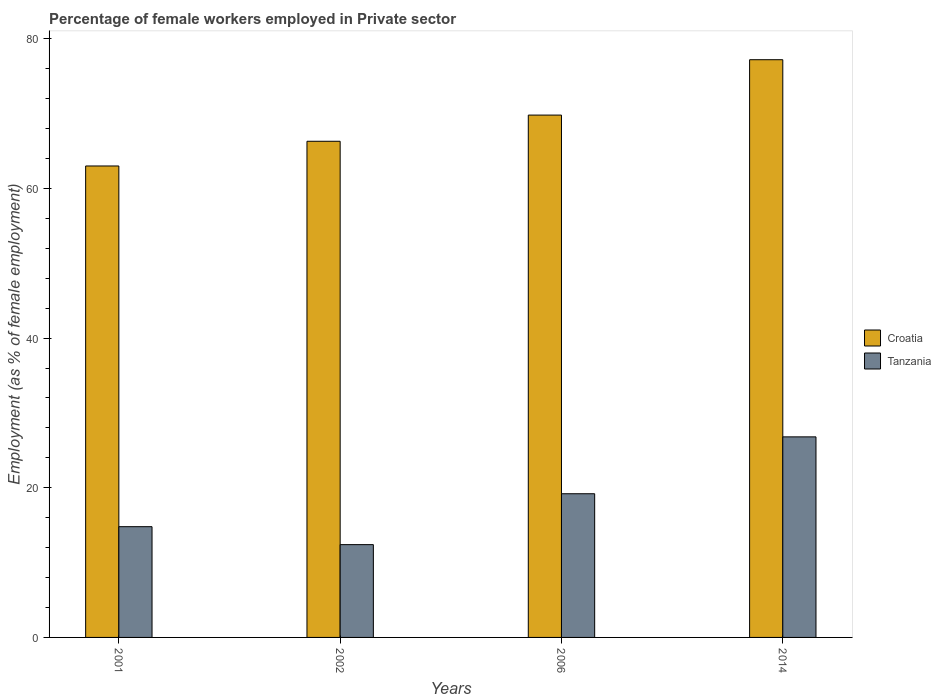How many groups of bars are there?
Your response must be concise. 4. Are the number of bars per tick equal to the number of legend labels?
Provide a succinct answer. Yes. How many bars are there on the 2nd tick from the right?
Provide a short and direct response. 2. What is the label of the 4th group of bars from the left?
Keep it short and to the point. 2014. What is the percentage of females employed in Private sector in Tanzania in 2014?
Your response must be concise. 26.8. Across all years, what is the maximum percentage of females employed in Private sector in Tanzania?
Make the answer very short. 26.8. Across all years, what is the minimum percentage of females employed in Private sector in Croatia?
Give a very brief answer. 63. In which year was the percentage of females employed in Private sector in Croatia maximum?
Ensure brevity in your answer.  2014. In which year was the percentage of females employed in Private sector in Croatia minimum?
Provide a succinct answer. 2001. What is the total percentage of females employed in Private sector in Tanzania in the graph?
Keep it short and to the point. 73.2. What is the difference between the percentage of females employed in Private sector in Tanzania in 2001 and that in 2006?
Provide a succinct answer. -4.4. What is the difference between the percentage of females employed in Private sector in Tanzania in 2001 and the percentage of females employed in Private sector in Croatia in 2006?
Provide a short and direct response. -55. What is the average percentage of females employed in Private sector in Tanzania per year?
Offer a very short reply. 18.3. In the year 2001, what is the difference between the percentage of females employed in Private sector in Croatia and percentage of females employed in Private sector in Tanzania?
Your response must be concise. 48.2. What is the ratio of the percentage of females employed in Private sector in Tanzania in 2002 to that in 2014?
Give a very brief answer. 0.46. Is the percentage of females employed in Private sector in Tanzania in 2001 less than that in 2002?
Keep it short and to the point. No. What is the difference between the highest and the second highest percentage of females employed in Private sector in Tanzania?
Provide a succinct answer. 7.6. What is the difference between the highest and the lowest percentage of females employed in Private sector in Tanzania?
Provide a short and direct response. 14.4. In how many years, is the percentage of females employed in Private sector in Tanzania greater than the average percentage of females employed in Private sector in Tanzania taken over all years?
Provide a short and direct response. 2. What does the 1st bar from the left in 2001 represents?
Give a very brief answer. Croatia. What does the 1st bar from the right in 2014 represents?
Offer a terse response. Tanzania. How many bars are there?
Keep it short and to the point. 8. How many years are there in the graph?
Keep it short and to the point. 4. Are the values on the major ticks of Y-axis written in scientific E-notation?
Provide a succinct answer. No. Does the graph contain any zero values?
Ensure brevity in your answer.  No. Does the graph contain grids?
Your response must be concise. No. Where does the legend appear in the graph?
Give a very brief answer. Center right. What is the title of the graph?
Provide a succinct answer. Percentage of female workers employed in Private sector. Does "Brunei Darussalam" appear as one of the legend labels in the graph?
Keep it short and to the point. No. What is the label or title of the X-axis?
Keep it short and to the point. Years. What is the label or title of the Y-axis?
Provide a short and direct response. Employment (as % of female employment). What is the Employment (as % of female employment) of Croatia in 2001?
Offer a terse response. 63. What is the Employment (as % of female employment) in Tanzania in 2001?
Make the answer very short. 14.8. What is the Employment (as % of female employment) in Croatia in 2002?
Provide a short and direct response. 66.3. What is the Employment (as % of female employment) in Tanzania in 2002?
Give a very brief answer. 12.4. What is the Employment (as % of female employment) in Croatia in 2006?
Keep it short and to the point. 69.8. What is the Employment (as % of female employment) of Tanzania in 2006?
Your response must be concise. 19.2. What is the Employment (as % of female employment) of Croatia in 2014?
Provide a short and direct response. 77.2. What is the Employment (as % of female employment) of Tanzania in 2014?
Ensure brevity in your answer.  26.8. Across all years, what is the maximum Employment (as % of female employment) in Croatia?
Make the answer very short. 77.2. Across all years, what is the maximum Employment (as % of female employment) in Tanzania?
Your answer should be very brief. 26.8. Across all years, what is the minimum Employment (as % of female employment) of Croatia?
Keep it short and to the point. 63. Across all years, what is the minimum Employment (as % of female employment) of Tanzania?
Your response must be concise. 12.4. What is the total Employment (as % of female employment) of Croatia in the graph?
Make the answer very short. 276.3. What is the total Employment (as % of female employment) in Tanzania in the graph?
Your answer should be compact. 73.2. What is the difference between the Employment (as % of female employment) of Croatia in 2001 and that in 2002?
Provide a short and direct response. -3.3. What is the difference between the Employment (as % of female employment) of Tanzania in 2001 and that in 2002?
Ensure brevity in your answer.  2.4. What is the difference between the Employment (as % of female employment) in Tanzania in 2001 and that in 2006?
Your answer should be very brief. -4.4. What is the difference between the Employment (as % of female employment) of Tanzania in 2001 and that in 2014?
Provide a short and direct response. -12. What is the difference between the Employment (as % of female employment) of Tanzania in 2002 and that in 2006?
Ensure brevity in your answer.  -6.8. What is the difference between the Employment (as % of female employment) of Tanzania in 2002 and that in 2014?
Offer a terse response. -14.4. What is the difference between the Employment (as % of female employment) of Tanzania in 2006 and that in 2014?
Make the answer very short. -7.6. What is the difference between the Employment (as % of female employment) of Croatia in 2001 and the Employment (as % of female employment) of Tanzania in 2002?
Give a very brief answer. 50.6. What is the difference between the Employment (as % of female employment) of Croatia in 2001 and the Employment (as % of female employment) of Tanzania in 2006?
Provide a succinct answer. 43.8. What is the difference between the Employment (as % of female employment) of Croatia in 2001 and the Employment (as % of female employment) of Tanzania in 2014?
Offer a very short reply. 36.2. What is the difference between the Employment (as % of female employment) in Croatia in 2002 and the Employment (as % of female employment) in Tanzania in 2006?
Your answer should be compact. 47.1. What is the difference between the Employment (as % of female employment) of Croatia in 2002 and the Employment (as % of female employment) of Tanzania in 2014?
Offer a terse response. 39.5. What is the average Employment (as % of female employment) of Croatia per year?
Make the answer very short. 69.08. What is the average Employment (as % of female employment) in Tanzania per year?
Give a very brief answer. 18.3. In the year 2001, what is the difference between the Employment (as % of female employment) in Croatia and Employment (as % of female employment) in Tanzania?
Offer a terse response. 48.2. In the year 2002, what is the difference between the Employment (as % of female employment) of Croatia and Employment (as % of female employment) of Tanzania?
Offer a very short reply. 53.9. In the year 2006, what is the difference between the Employment (as % of female employment) in Croatia and Employment (as % of female employment) in Tanzania?
Your answer should be compact. 50.6. In the year 2014, what is the difference between the Employment (as % of female employment) in Croatia and Employment (as % of female employment) in Tanzania?
Provide a short and direct response. 50.4. What is the ratio of the Employment (as % of female employment) in Croatia in 2001 to that in 2002?
Keep it short and to the point. 0.95. What is the ratio of the Employment (as % of female employment) in Tanzania in 2001 to that in 2002?
Your response must be concise. 1.19. What is the ratio of the Employment (as % of female employment) of Croatia in 2001 to that in 2006?
Provide a succinct answer. 0.9. What is the ratio of the Employment (as % of female employment) in Tanzania in 2001 to that in 2006?
Your answer should be very brief. 0.77. What is the ratio of the Employment (as % of female employment) of Croatia in 2001 to that in 2014?
Give a very brief answer. 0.82. What is the ratio of the Employment (as % of female employment) in Tanzania in 2001 to that in 2014?
Give a very brief answer. 0.55. What is the ratio of the Employment (as % of female employment) in Croatia in 2002 to that in 2006?
Ensure brevity in your answer.  0.95. What is the ratio of the Employment (as % of female employment) of Tanzania in 2002 to that in 2006?
Offer a terse response. 0.65. What is the ratio of the Employment (as % of female employment) of Croatia in 2002 to that in 2014?
Your answer should be compact. 0.86. What is the ratio of the Employment (as % of female employment) in Tanzania in 2002 to that in 2014?
Give a very brief answer. 0.46. What is the ratio of the Employment (as % of female employment) in Croatia in 2006 to that in 2014?
Make the answer very short. 0.9. What is the ratio of the Employment (as % of female employment) in Tanzania in 2006 to that in 2014?
Provide a succinct answer. 0.72. What is the difference between the highest and the second highest Employment (as % of female employment) in Croatia?
Ensure brevity in your answer.  7.4. What is the difference between the highest and the second highest Employment (as % of female employment) of Tanzania?
Ensure brevity in your answer.  7.6. What is the difference between the highest and the lowest Employment (as % of female employment) in Croatia?
Make the answer very short. 14.2. What is the difference between the highest and the lowest Employment (as % of female employment) in Tanzania?
Provide a succinct answer. 14.4. 